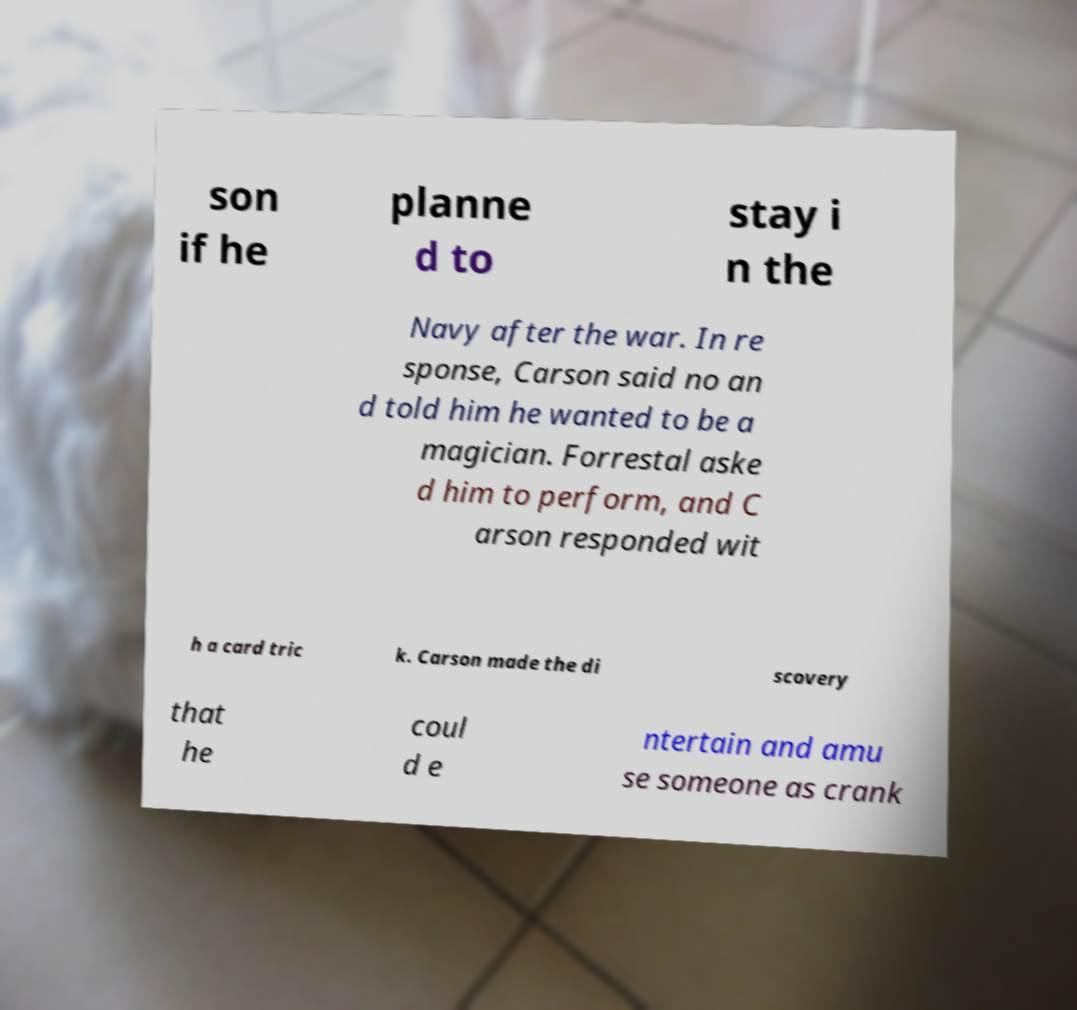Can you accurately transcribe the text from the provided image for me? son if he planne d to stay i n the Navy after the war. In re sponse, Carson said no an d told him he wanted to be a magician. Forrestal aske d him to perform, and C arson responded wit h a card tric k. Carson made the di scovery that he coul d e ntertain and amu se someone as crank 